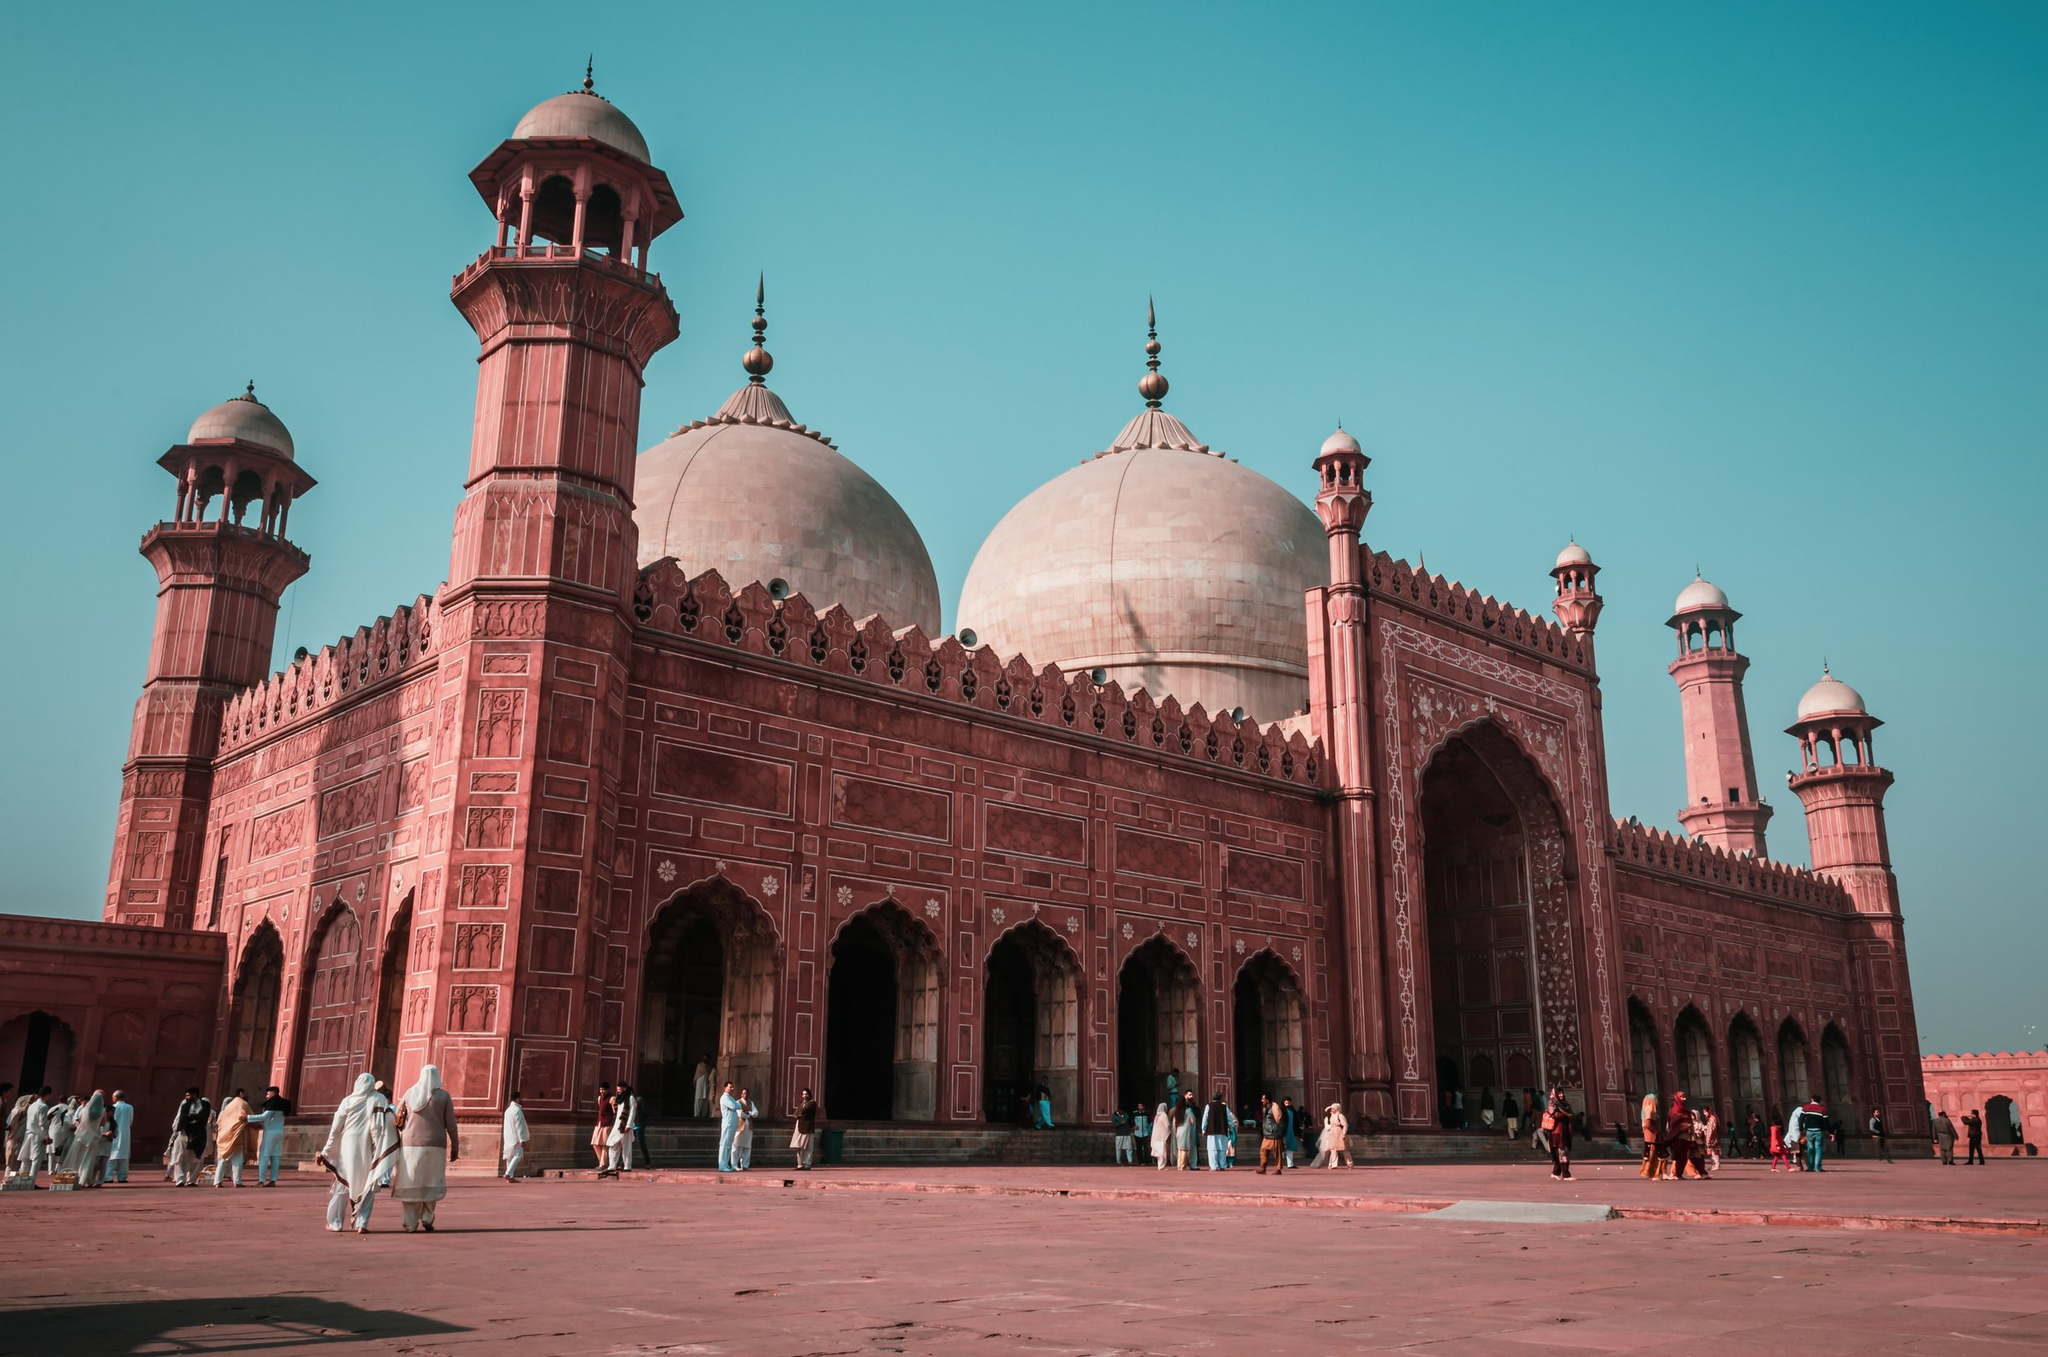Describe a short realistic scenario about what might be happening in this image. In this image, a group of tourists is taking a guided tour of the Badshahi Mosque. They are listening attentively as the guide explains the historical significance and architectural details of the mosque. Some visitors are taking photographs, while others are quietly reflecting on the beauty and serenity of the place. 